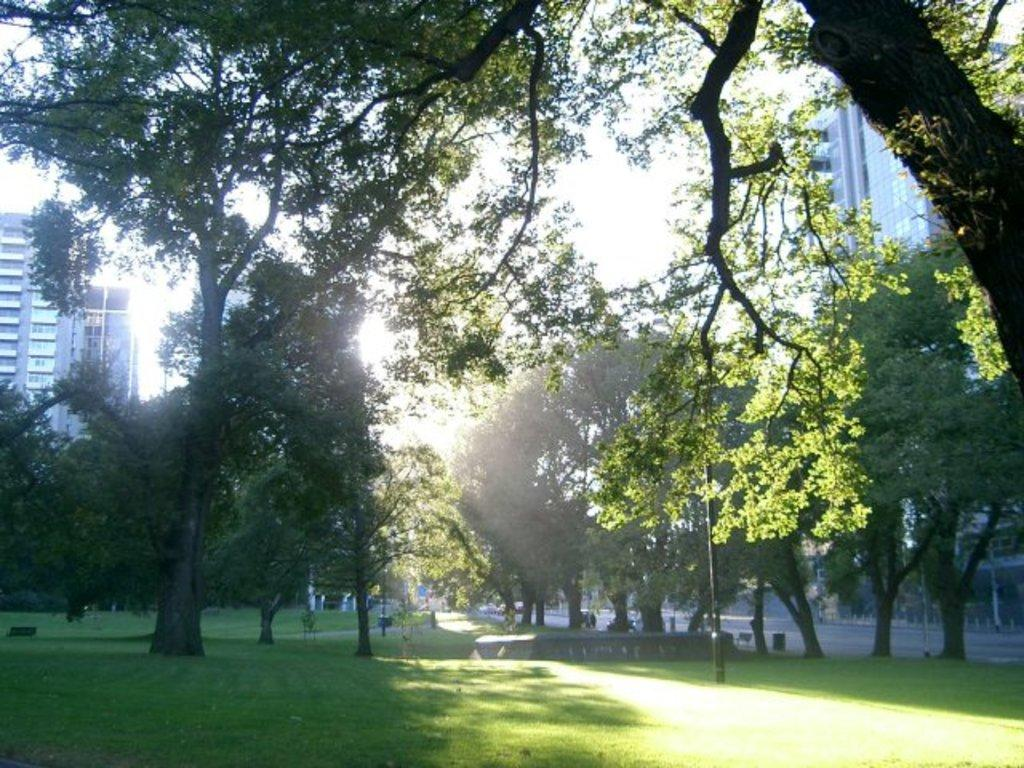What type of vegetation is present in the image? There are trees in the image. What is the color of the trees? The trees are green. How many buildings can be seen in the image? There are two buildings in the image. What is the color of the buildings? The buildings are white. What part of the natural environment is visible in the image? The sky is visible in the image. What is the color of the sky? The sky is white. Where is the cup placed in the image? There is no cup present in the image. What type of crib is visible in the image? There is no crib present in the image. 